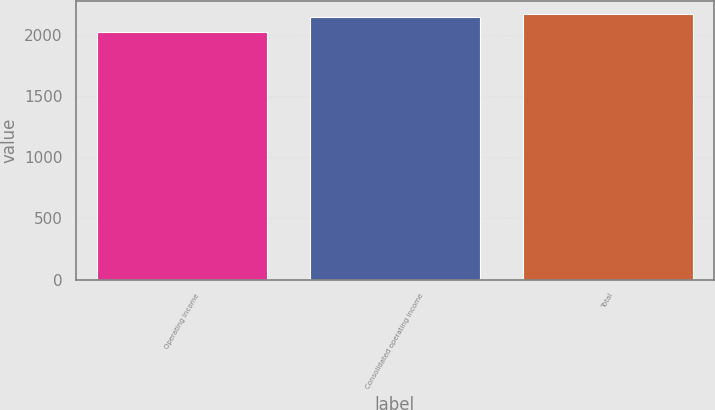Convert chart. <chart><loc_0><loc_0><loc_500><loc_500><bar_chart><fcel>Operating Income<fcel>Consolidated operating income<fcel>Total<nl><fcel>2019<fcel>2144.4<fcel>2169.8<nl></chart> 